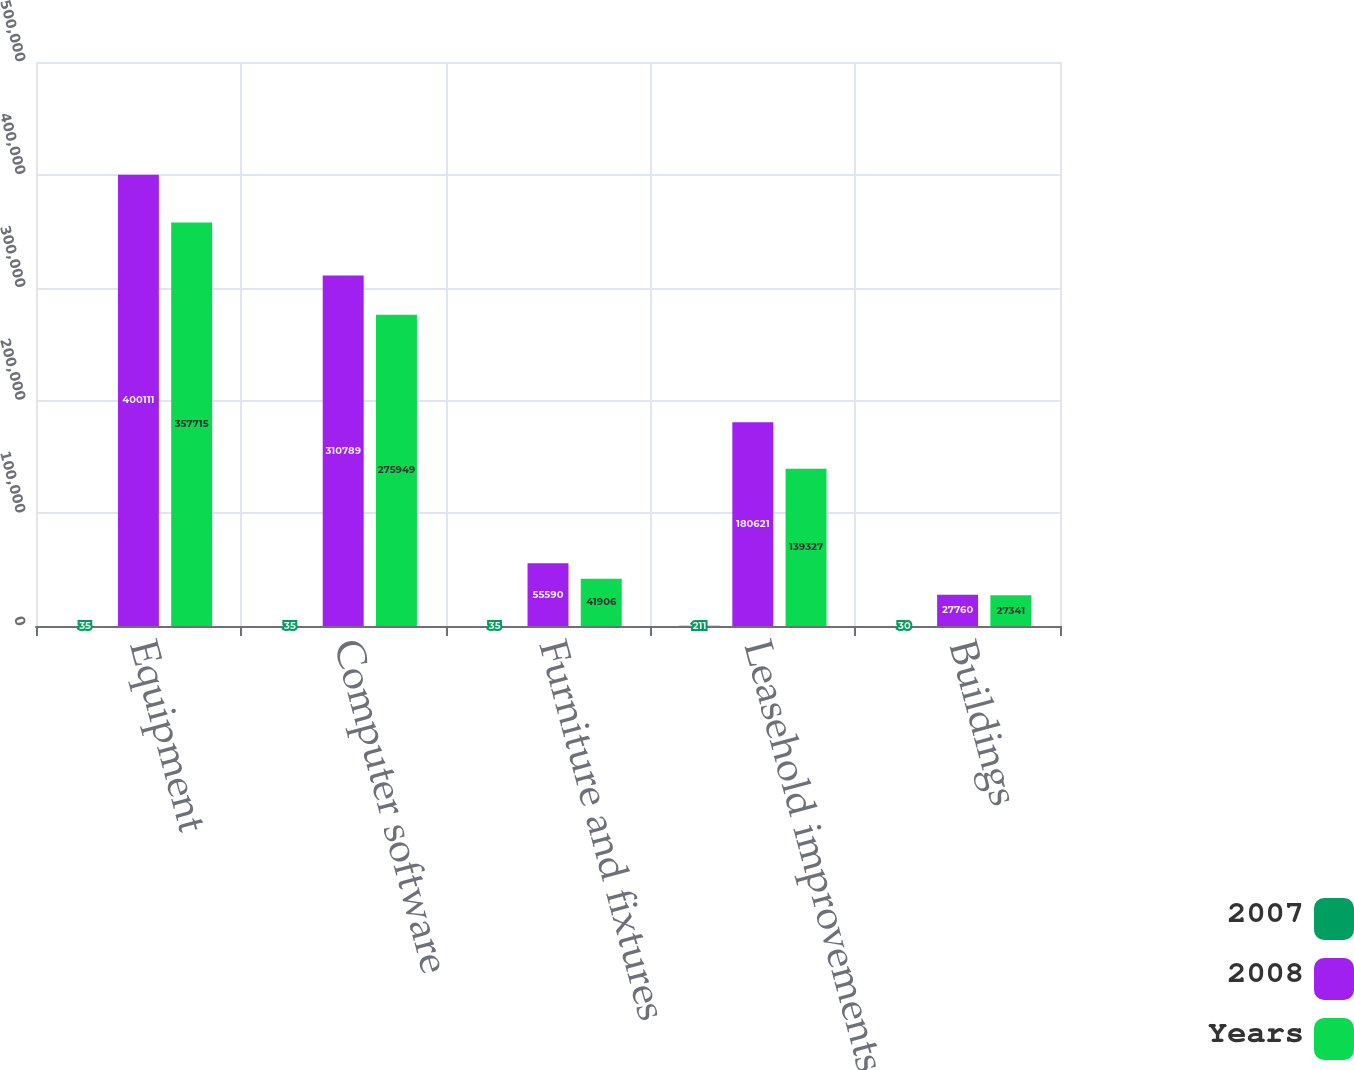Convert chart to OTSL. <chart><loc_0><loc_0><loc_500><loc_500><stacked_bar_chart><ecel><fcel>Equipment<fcel>Computer software<fcel>Furniture and fixtures<fcel>Leasehold improvements<fcel>Buildings<nl><fcel>2007<fcel>35<fcel>35<fcel>35<fcel>211<fcel>30<nl><fcel>2008<fcel>400111<fcel>310789<fcel>55590<fcel>180621<fcel>27760<nl><fcel>Years<fcel>357715<fcel>275949<fcel>41906<fcel>139327<fcel>27341<nl></chart> 